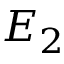<formula> <loc_0><loc_0><loc_500><loc_500>E _ { 2 }</formula> 